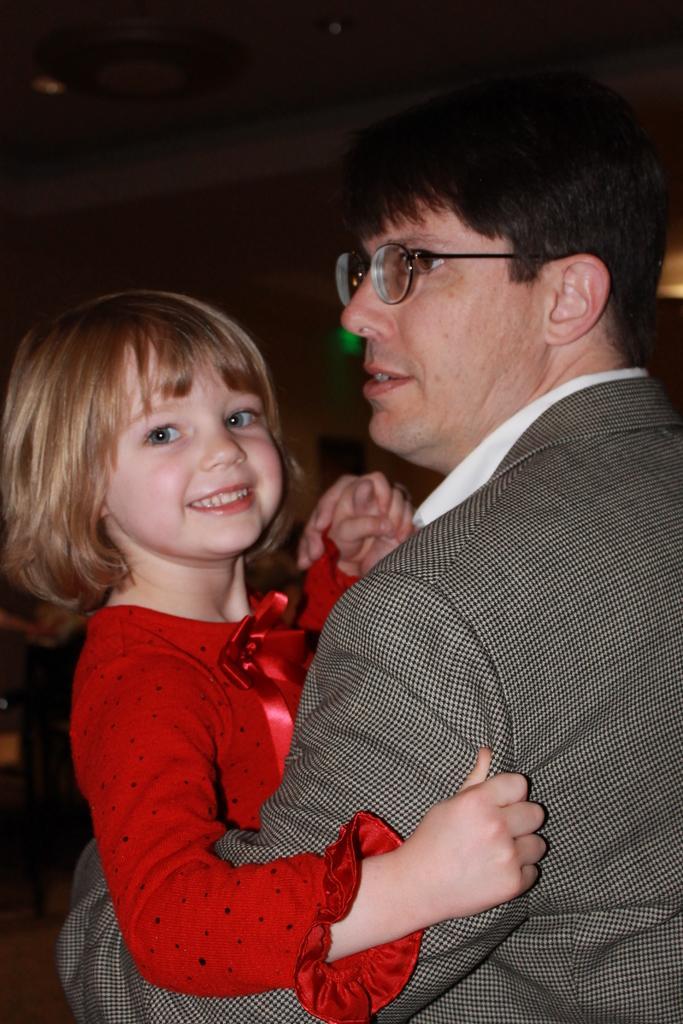How would you summarize this image in a sentence or two? Here in this picture we can see a man in a suit holding a child in a red colored dress in his hands and the child is smiling and we can see spectacles on the man over there. 